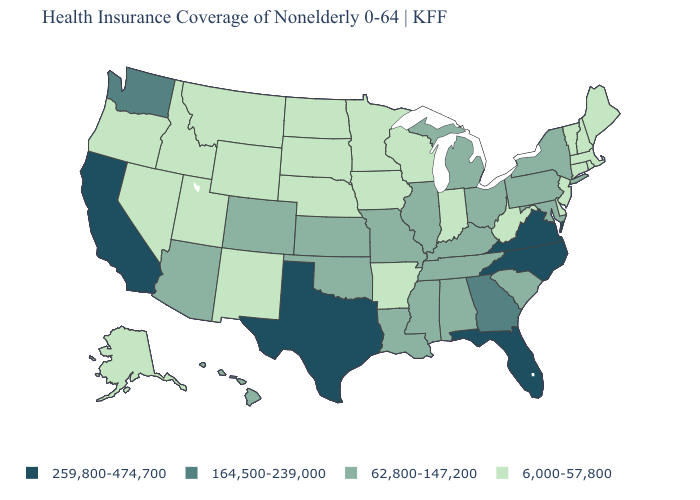What is the value of Kansas?
Short answer required. 62,800-147,200. Name the states that have a value in the range 164,500-239,000?
Answer briefly. Georgia, Washington. Which states have the highest value in the USA?
Keep it brief. California, Florida, North Carolina, Texas, Virginia. What is the value of South Carolina?
Answer briefly. 62,800-147,200. Which states have the highest value in the USA?
Answer briefly. California, Florida, North Carolina, Texas, Virginia. Does the map have missing data?
Keep it brief. No. Which states hav the highest value in the South?
Short answer required. Florida, North Carolina, Texas, Virginia. What is the highest value in the USA?
Give a very brief answer. 259,800-474,700. Among the states that border Florida , which have the lowest value?
Be succinct. Alabama. Name the states that have a value in the range 164,500-239,000?
Concise answer only. Georgia, Washington. Name the states that have a value in the range 164,500-239,000?
Keep it brief. Georgia, Washington. Name the states that have a value in the range 259,800-474,700?
Be succinct. California, Florida, North Carolina, Texas, Virginia. What is the value of Connecticut?
Write a very short answer. 6,000-57,800. 